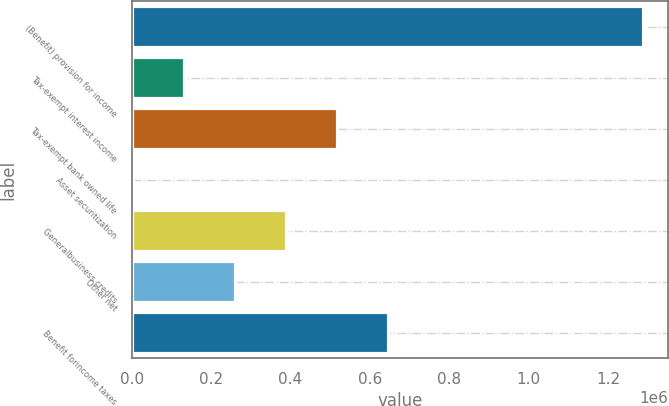Convert chart to OTSL. <chart><loc_0><loc_0><loc_500><loc_500><bar_chart><fcel>(Benefit) provision for income<fcel>Tax-exempt interest income<fcel>Tax-exempt bank owned life<fcel>Asset securitization<fcel>Generalbusiness credits<fcel>Other net<fcel>Benefit forincome taxes<nl><fcel>1.28736e+06<fcel>131598<fcel>516853<fcel>3179<fcel>388434<fcel>260016<fcel>645272<nl></chart> 